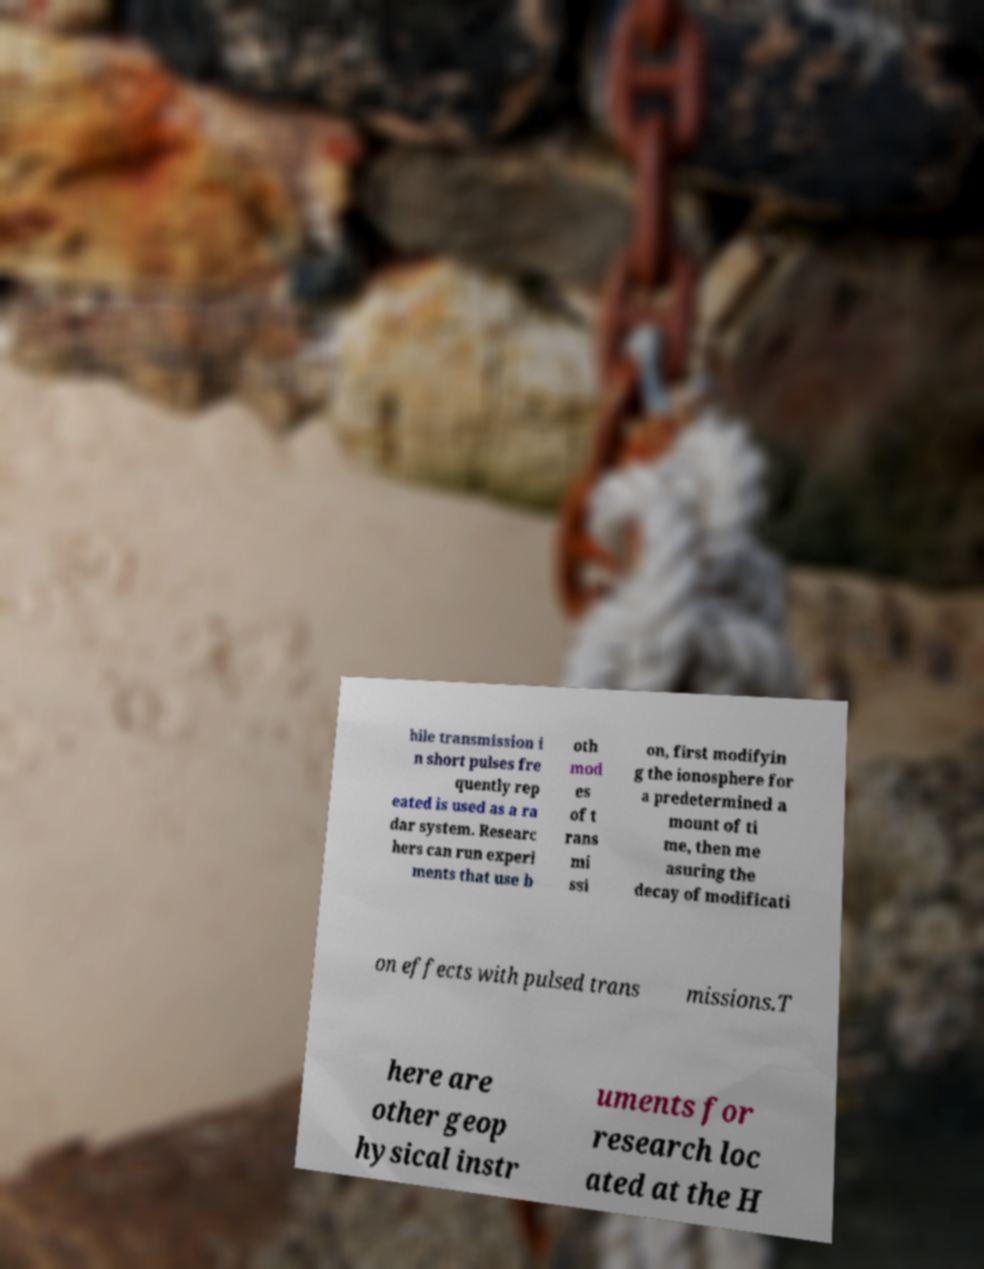Could you extract and type out the text from this image? hile transmission i n short pulses fre quently rep eated is used as a ra dar system. Researc hers can run experi ments that use b oth mod es of t rans mi ssi on, first modifyin g the ionosphere for a predetermined a mount of ti me, then me asuring the decay of modificati on effects with pulsed trans missions.T here are other geop hysical instr uments for research loc ated at the H 